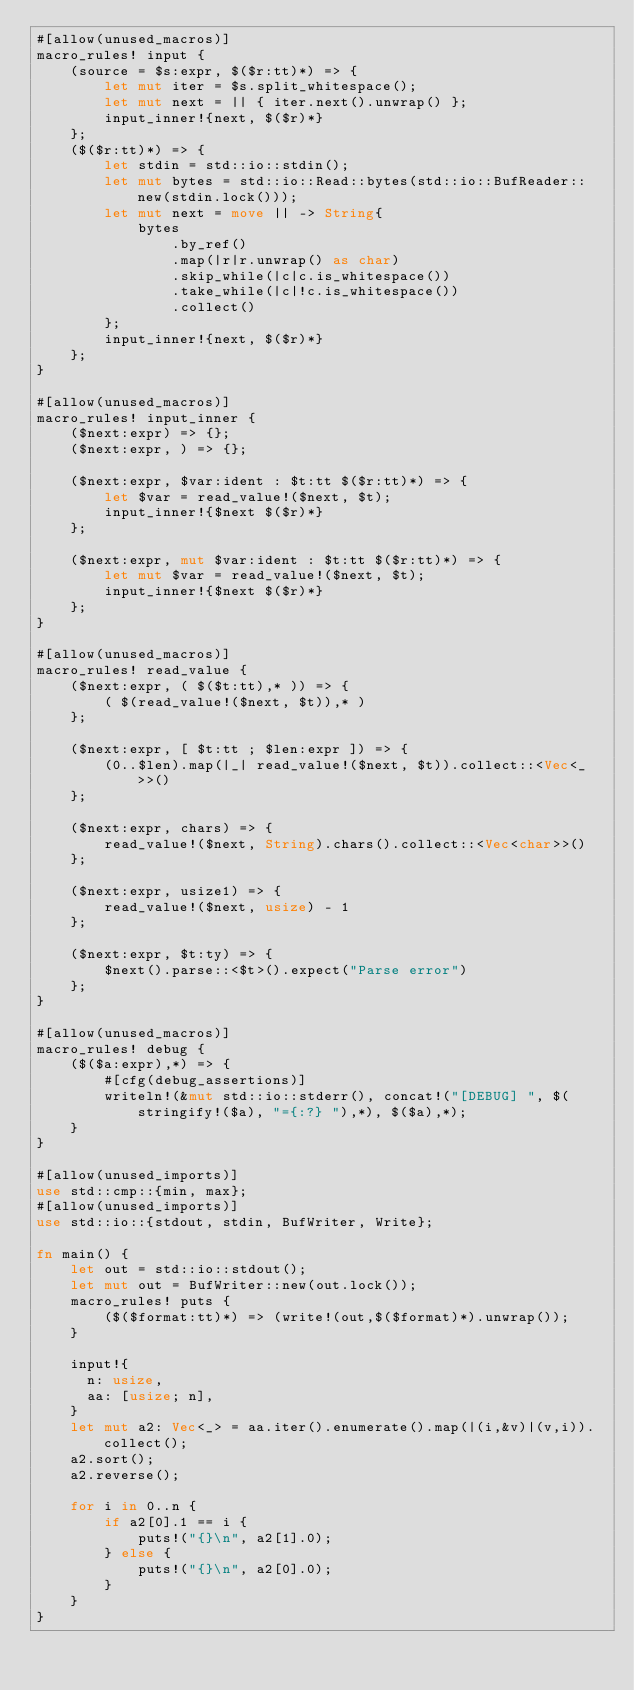Convert code to text. <code><loc_0><loc_0><loc_500><loc_500><_Rust_>#[allow(unused_macros)]
macro_rules! input {
    (source = $s:expr, $($r:tt)*) => {
        let mut iter = $s.split_whitespace();
        let mut next = || { iter.next().unwrap() };
        input_inner!{next, $($r)*}
    };
    ($($r:tt)*) => {
        let stdin = std::io::stdin();
        let mut bytes = std::io::Read::bytes(std::io::BufReader::new(stdin.lock()));
        let mut next = move || -> String{
            bytes
                .by_ref()
                .map(|r|r.unwrap() as char)
                .skip_while(|c|c.is_whitespace())
                .take_while(|c|!c.is_whitespace())
                .collect()
        };
        input_inner!{next, $($r)*}
    };
}

#[allow(unused_macros)]
macro_rules! input_inner {
    ($next:expr) => {};
    ($next:expr, ) => {};

    ($next:expr, $var:ident : $t:tt $($r:tt)*) => {
        let $var = read_value!($next, $t);
        input_inner!{$next $($r)*}
    };

    ($next:expr, mut $var:ident : $t:tt $($r:tt)*) => {
        let mut $var = read_value!($next, $t);
        input_inner!{$next $($r)*}
    };
}

#[allow(unused_macros)]
macro_rules! read_value {
    ($next:expr, ( $($t:tt),* )) => {
        ( $(read_value!($next, $t)),* )
    };

    ($next:expr, [ $t:tt ; $len:expr ]) => {
        (0..$len).map(|_| read_value!($next, $t)).collect::<Vec<_>>()
    };

    ($next:expr, chars) => {
        read_value!($next, String).chars().collect::<Vec<char>>()
    };

    ($next:expr, usize1) => {
        read_value!($next, usize) - 1
    };

    ($next:expr, $t:ty) => {
        $next().parse::<$t>().expect("Parse error")
    };
}

#[allow(unused_macros)]
macro_rules! debug {
    ($($a:expr),*) => {
        #[cfg(debug_assertions)]
        writeln!(&mut std::io::stderr(), concat!("[DEBUG] ", $(stringify!($a), "={:?} "),*), $($a),*);
    }
}

#[allow(unused_imports)]
use std::cmp::{min, max};
#[allow(unused_imports)]
use std::io::{stdout, stdin, BufWriter, Write};

fn main() {
    let out = std::io::stdout();
    let mut out = BufWriter::new(out.lock());
    macro_rules! puts {
        ($($format:tt)*) => (write!(out,$($format)*).unwrap());
    }

    input!{
      n: usize,
      aa: [usize; n],
    }
    let mut a2: Vec<_> = aa.iter().enumerate().map(|(i,&v)|(v,i)).collect();
    a2.sort();
    a2.reverse();

    for i in 0..n {
        if a2[0].1 == i {
            puts!("{}\n", a2[1].0);
        } else {
            puts!("{}\n", a2[0].0);
        }
    }
}
</code> 